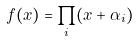<formula> <loc_0><loc_0><loc_500><loc_500>f ( x ) = \prod _ { i } ( x + \alpha _ { i } )</formula> 